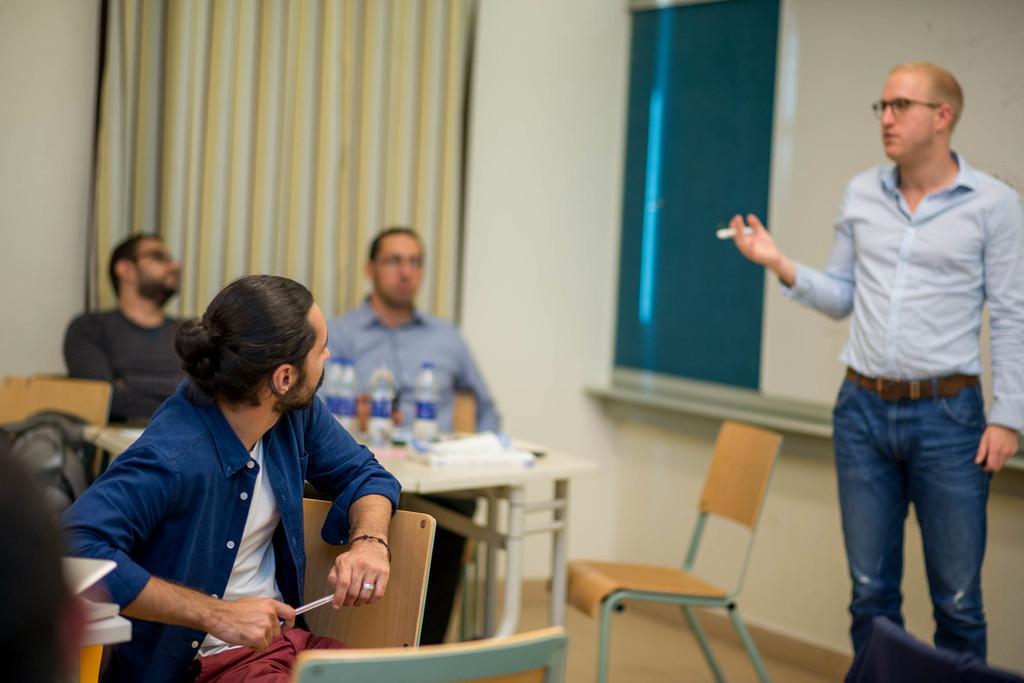In one or two sentences, can you explain what this image depicts? In this image I can see few people where few of them are sitting and a man is standing. I can also see few bottles, chairs and a table. 